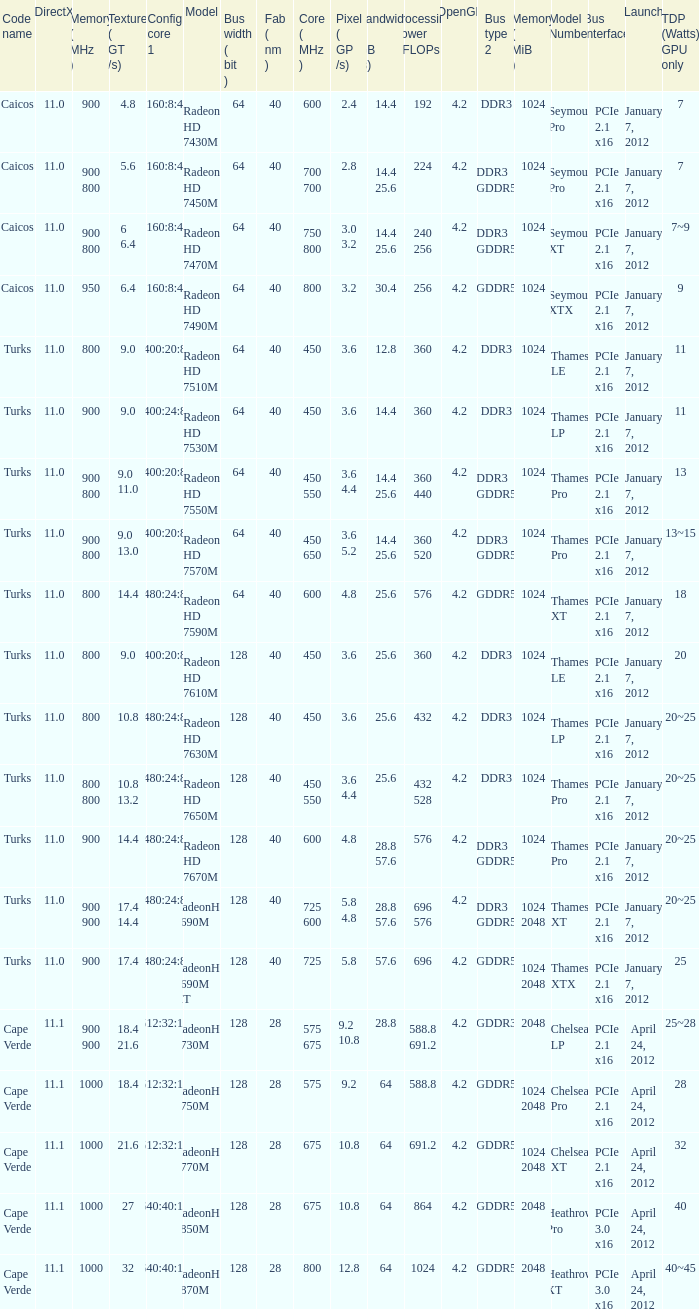What was the maximum fab (nm)? 40.0. 